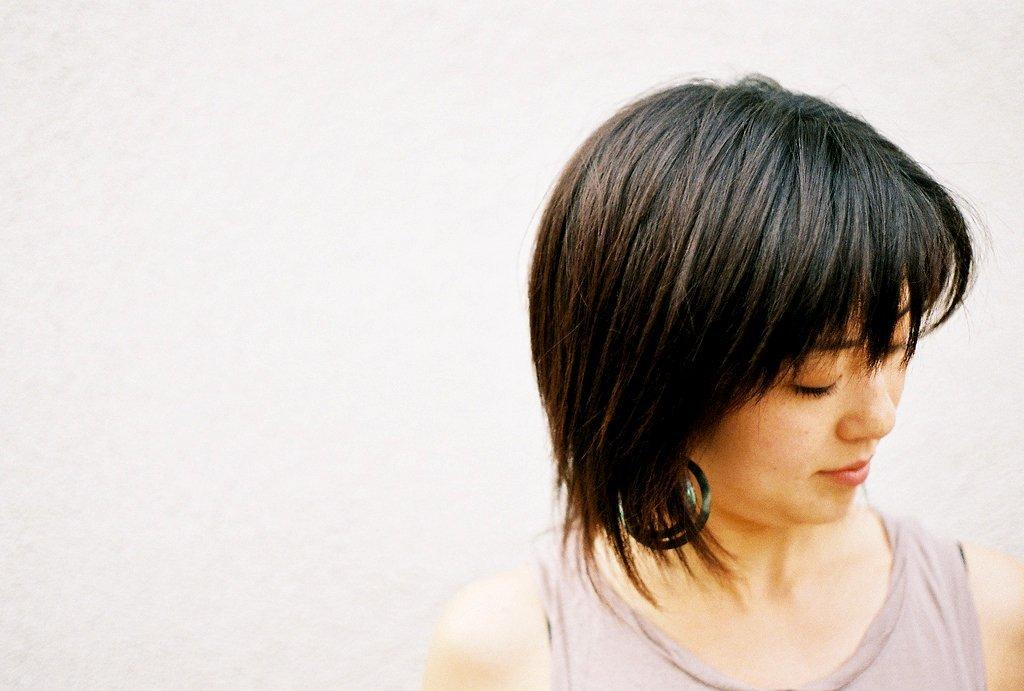What is the main subject of the image? There is a person in the image, but they are truncated towards the bottom. Can you describe the background of the image? There is a wall in the background of the image, but it is also truncated. What type of plane can be seen flying in the image? There is no plane visible in the image. What attraction is present in the image? There is: A: There is no attraction mentioned in the provided facts; the image only features a truncated person and a truncated wall in the background. 